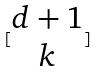Convert formula to latex. <formula><loc_0><loc_0><loc_500><loc_500>[ \begin{matrix} d + 1 \\ k \end{matrix} ]</formula> 